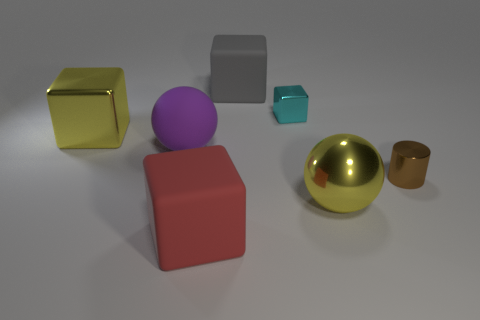How do the textures of the objects compare? The objects in the image display a variety of textures. The large yellow cube has a reflective surface that looks metallic, indicating it's likely a smooth and polished object. The purple sphere seems to have a matte finish typical for rubber, giving it a non-reflective and slightly textured appearance. The silver cylinder in the center has a satin-like finish, which is less reflective than the yellow cube but smoother than the purple sphere.  Which object looks the heaviest? Judging by size and material, the yellow cube appears to be the heaviest. Its size relative to the other objects is considerable, and if it is made of metal as it appears to be, its density would contribute to a higher weight compared to the other objects, which seem to be made of lighter materials like plastic or rubber. 